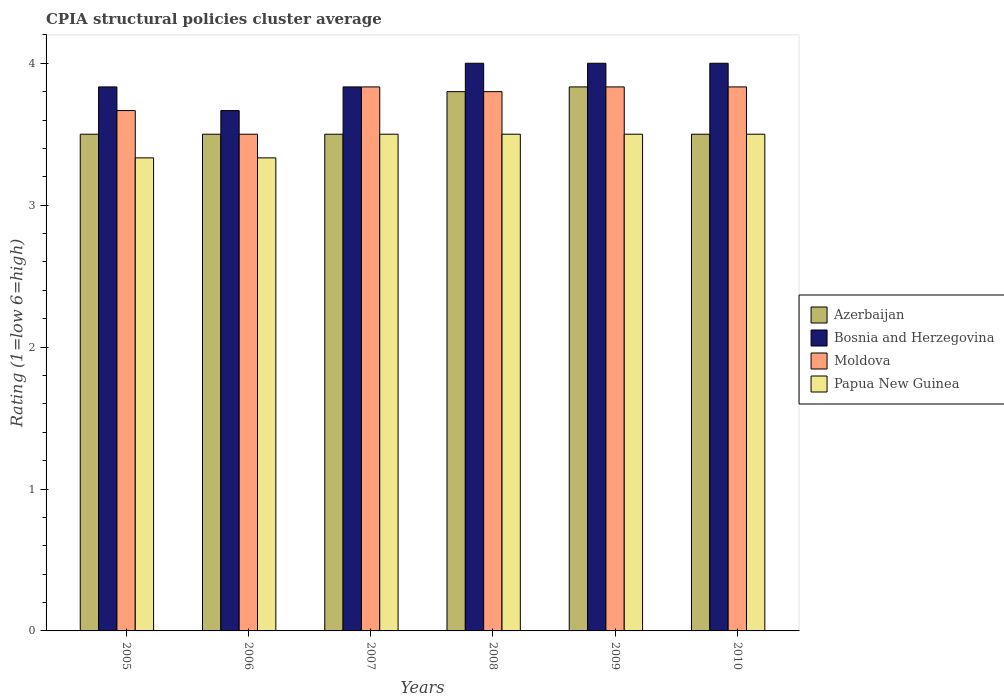How many different coloured bars are there?
Your answer should be very brief. 4. How many bars are there on the 4th tick from the left?
Provide a short and direct response. 4. What is the label of the 6th group of bars from the left?
Give a very brief answer. 2010. In how many cases, is the number of bars for a given year not equal to the number of legend labels?
Your answer should be compact. 0. What is the CPIA rating in Bosnia and Herzegovina in 2005?
Offer a very short reply. 3.83. Across all years, what is the maximum CPIA rating in Moldova?
Your response must be concise. 3.83. Across all years, what is the minimum CPIA rating in Azerbaijan?
Give a very brief answer. 3.5. What is the total CPIA rating in Azerbaijan in the graph?
Your answer should be compact. 21.63. What is the average CPIA rating in Moldova per year?
Offer a very short reply. 3.74. In the year 2007, what is the difference between the CPIA rating in Bosnia and Herzegovina and CPIA rating in Azerbaijan?
Offer a very short reply. 0.33. In how many years, is the CPIA rating in Papua New Guinea greater than 1?
Your answer should be compact. 6. What is the ratio of the CPIA rating in Azerbaijan in 2006 to that in 2008?
Give a very brief answer. 0.92. Is the CPIA rating in Moldova in 2007 less than that in 2008?
Offer a very short reply. No. Is the difference between the CPIA rating in Bosnia and Herzegovina in 2009 and 2010 greater than the difference between the CPIA rating in Azerbaijan in 2009 and 2010?
Your answer should be very brief. No. What is the difference between the highest and the second highest CPIA rating in Azerbaijan?
Offer a very short reply. 0.03. What is the difference between the highest and the lowest CPIA rating in Papua New Guinea?
Your answer should be very brief. 0.17. In how many years, is the CPIA rating in Bosnia and Herzegovina greater than the average CPIA rating in Bosnia and Herzegovina taken over all years?
Your answer should be very brief. 3. Is the sum of the CPIA rating in Azerbaijan in 2005 and 2006 greater than the maximum CPIA rating in Papua New Guinea across all years?
Ensure brevity in your answer.  Yes. What does the 1st bar from the left in 2005 represents?
Ensure brevity in your answer.  Azerbaijan. What does the 3rd bar from the right in 2007 represents?
Offer a very short reply. Bosnia and Herzegovina. How many years are there in the graph?
Offer a terse response. 6. What is the difference between two consecutive major ticks on the Y-axis?
Give a very brief answer. 1. Does the graph contain grids?
Your answer should be very brief. No. Where does the legend appear in the graph?
Provide a succinct answer. Center right. How many legend labels are there?
Provide a succinct answer. 4. How are the legend labels stacked?
Provide a succinct answer. Vertical. What is the title of the graph?
Your answer should be very brief. CPIA structural policies cluster average. Does "Burkina Faso" appear as one of the legend labels in the graph?
Give a very brief answer. No. What is the label or title of the Y-axis?
Your response must be concise. Rating (1=low 6=high). What is the Rating (1=low 6=high) of Bosnia and Herzegovina in 2005?
Ensure brevity in your answer.  3.83. What is the Rating (1=low 6=high) of Moldova in 2005?
Ensure brevity in your answer.  3.67. What is the Rating (1=low 6=high) of Papua New Guinea in 2005?
Give a very brief answer. 3.33. What is the Rating (1=low 6=high) in Azerbaijan in 2006?
Your answer should be compact. 3.5. What is the Rating (1=low 6=high) in Bosnia and Herzegovina in 2006?
Ensure brevity in your answer.  3.67. What is the Rating (1=low 6=high) in Moldova in 2006?
Give a very brief answer. 3.5. What is the Rating (1=low 6=high) in Papua New Guinea in 2006?
Give a very brief answer. 3.33. What is the Rating (1=low 6=high) of Bosnia and Herzegovina in 2007?
Keep it short and to the point. 3.83. What is the Rating (1=low 6=high) of Moldova in 2007?
Offer a terse response. 3.83. What is the Rating (1=low 6=high) of Papua New Guinea in 2007?
Give a very brief answer. 3.5. What is the Rating (1=low 6=high) of Azerbaijan in 2008?
Offer a terse response. 3.8. What is the Rating (1=low 6=high) of Bosnia and Herzegovina in 2008?
Provide a short and direct response. 4. What is the Rating (1=low 6=high) of Papua New Guinea in 2008?
Offer a terse response. 3.5. What is the Rating (1=low 6=high) in Azerbaijan in 2009?
Make the answer very short. 3.83. What is the Rating (1=low 6=high) of Moldova in 2009?
Provide a succinct answer. 3.83. What is the Rating (1=low 6=high) in Azerbaijan in 2010?
Your answer should be compact. 3.5. What is the Rating (1=low 6=high) of Bosnia and Herzegovina in 2010?
Ensure brevity in your answer.  4. What is the Rating (1=low 6=high) in Moldova in 2010?
Ensure brevity in your answer.  3.83. What is the Rating (1=low 6=high) in Papua New Guinea in 2010?
Offer a terse response. 3.5. Across all years, what is the maximum Rating (1=low 6=high) of Azerbaijan?
Provide a succinct answer. 3.83. Across all years, what is the maximum Rating (1=low 6=high) of Moldova?
Your answer should be very brief. 3.83. Across all years, what is the minimum Rating (1=low 6=high) of Azerbaijan?
Provide a short and direct response. 3.5. Across all years, what is the minimum Rating (1=low 6=high) in Bosnia and Herzegovina?
Your answer should be compact. 3.67. Across all years, what is the minimum Rating (1=low 6=high) in Papua New Guinea?
Give a very brief answer. 3.33. What is the total Rating (1=low 6=high) of Azerbaijan in the graph?
Offer a very short reply. 21.63. What is the total Rating (1=low 6=high) in Bosnia and Herzegovina in the graph?
Your answer should be compact. 23.33. What is the total Rating (1=low 6=high) in Moldova in the graph?
Your answer should be very brief. 22.47. What is the total Rating (1=low 6=high) of Papua New Guinea in the graph?
Your answer should be compact. 20.67. What is the difference between the Rating (1=low 6=high) of Azerbaijan in 2005 and that in 2006?
Keep it short and to the point. 0. What is the difference between the Rating (1=low 6=high) in Papua New Guinea in 2005 and that in 2006?
Provide a succinct answer. 0. What is the difference between the Rating (1=low 6=high) of Moldova in 2005 and that in 2007?
Offer a very short reply. -0.17. What is the difference between the Rating (1=low 6=high) of Papua New Guinea in 2005 and that in 2007?
Provide a succinct answer. -0.17. What is the difference between the Rating (1=low 6=high) in Azerbaijan in 2005 and that in 2008?
Make the answer very short. -0.3. What is the difference between the Rating (1=low 6=high) in Bosnia and Herzegovina in 2005 and that in 2008?
Make the answer very short. -0.17. What is the difference between the Rating (1=low 6=high) of Moldova in 2005 and that in 2008?
Your response must be concise. -0.13. What is the difference between the Rating (1=low 6=high) of Azerbaijan in 2005 and that in 2009?
Offer a terse response. -0.33. What is the difference between the Rating (1=low 6=high) in Bosnia and Herzegovina in 2005 and that in 2009?
Your answer should be very brief. -0.17. What is the difference between the Rating (1=low 6=high) of Moldova in 2005 and that in 2009?
Ensure brevity in your answer.  -0.17. What is the difference between the Rating (1=low 6=high) in Papua New Guinea in 2005 and that in 2009?
Give a very brief answer. -0.17. What is the difference between the Rating (1=low 6=high) in Bosnia and Herzegovina in 2005 and that in 2010?
Your response must be concise. -0.17. What is the difference between the Rating (1=low 6=high) of Papua New Guinea in 2005 and that in 2010?
Provide a short and direct response. -0.17. What is the difference between the Rating (1=low 6=high) in Azerbaijan in 2006 and that in 2007?
Ensure brevity in your answer.  0. What is the difference between the Rating (1=low 6=high) of Bosnia and Herzegovina in 2006 and that in 2007?
Your answer should be very brief. -0.17. What is the difference between the Rating (1=low 6=high) of Moldova in 2006 and that in 2007?
Provide a short and direct response. -0.33. What is the difference between the Rating (1=low 6=high) in Azerbaijan in 2006 and that in 2008?
Provide a short and direct response. -0.3. What is the difference between the Rating (1=low 6=high) of Moldova in 2006 and that in 2008?
Your response must be concise. -0.3. What is the difference between the Rating (1=low 6=high) of Papua New Guinea in 2006 and that in 2008?
Offer a very short reply. -0.17. What is the difference between the Rating (1=low 6=high) of Azerbaijan in 2006 and that in 2009?
Make the answer very short. -0.33. What is the difference between the Rating (1=low 6=high) of Bosnia and Herzegovina in 2006 and that in 2009?
Your response must be concise. -0.33. What is the difference between the Rating (1=low 6=high) of Papua New Guinea in 2006 and that in 2009?
Your response must be concise. -0.17. What is the difference between the Rating (1=low 6=high) in Azerbaijan in 2006 and that in 2010?
Provide a short and direct response. 0. What is the difference between the Rating (1=low 6=high) of Bosnia and Herzegovina in 2006 and that in 2010?
Offer a very short reply. -0.33. What is the difference between the Rating (1=low 6=high) in Moldova in 2007 and that in 2008?
Your answer should be compact. 0.03. What is the difference between the Rating (1=low 6=high) of Bosnia and Herzegovina in 2007 and that in 2009?
Your response must be concise. -0.17. What is the difference between the Rating (1=low 6=high) in Papua New Guinea in 2007 and that in 2009?
Provide a succinct answer. 0. What is the difference between the Rating (1=low 6=high) in Moldova in 2007 and that in 2010?
Provide a short and direct response. 0. What is the difference between the Rating (1=low 6=high) of Azerbaijan in 2008 and that in 2009?
Provide a succinct answer. -0.03. What is the difference between the Rating (1=low 6=high) in Bosnia and Herzegovina in 2008 and that in 2009?
Give a very brief answer. 0. What is the difference between the Rating (1=low 6=high) in Moldova in 2008 and that in 2009?
Keep it short and to the point. -0.03. What is the difference between the Rating (1=low 6=high) in Azerbaijan in 2008 and that in 2010?
Provide a short and direct response. 0.3. What is the difference between the Rating (1=low 6=high) in Moldova in 2008 and that in 2010?
Give a very brief answer. -0.03. What is the difference between the Rating (1=low 6=high) of Bosnia and Herzegovina in 2009 and that in 2010?
Provide a short and direct response. 0. What is the difference between the Rating (1=low 6=high) in Moldova in 2009 and that in 2010?
Your response must be concise. 0. What is the difference between the Rating (1=low 6=high) of Azerbaijan in 2005 and the Rating (1=low 6=high) of Papua New Guinea in 2006?
Offer a terse response. 0.17. What is the difference between the Rating (1=low 6=high) in Bosnia and Herzegovina in 2005 and the Rating (1=low 6=high) in Moldova in 2006?
Offer a very short reply. 0.33. What is the difference between the Rating (1=low 6=high) in Bosnia and Herzegovina in 2005 and the Rating (1=low 6=high) in Papua New Guinea in 2006?
Provide a succinct answer. 0.5. What is the difference between the Rating (1=low 6=high) of Azerbaijan in 2005 and the Rating (1=low 6=high) of Bosnia and Herzegovina in 2007?
Your response must be concise. -0.33. What is the difference between the Rating (1=low 6=high) of Bosnia and Herzegovina in 2005 and the Rating (1=low 6=high) of Moldova in 2007?
Your answer should be very brief. 0. What is the difference between the Rating (1=low 6=high) in Moldova in 2005 and the Rating (1=low 6=high) in Papua New Guinea in 2007?
Make the answer very short. 0.17. What is the difference between the Rating (1=low 6=high) of Azerbaijan in 2005 and the Rating (1=low 6=high) of Moldova in 2008?
Keep it short and to the point. -0.3. What is the difference between the Rating (1=low 6=high) in Azerbaijan in 2005 and the Rating (1=low 6=high) in Papua New Guinea in 2008?
Offer a very short reply. 0. What is the difference between the Rating (1=low 6=high) of Bosnia and Herzegovina in 2005 and the Rating (1=low 6=high) of Moldova in 2008?
Your answer should be very brief. 0.03. What is the difference between the Rating (1=low 6=high) of Bosnia and Herzegovina in 2005 and the Rating (1=low 6=high) of Papua New Guinea in 2008?
Make the answer very short. 0.33. What is the difference between the Rating (1=low 6=high) in Moldova in 2005 and the Rating (1=low 6=high) in Papua New Guinea in 2008?
Your response must be concise. 0.17. What is the difference between the Rating (1=low 6=high) in Azerbaijan in 2005 and the Rating (1=low 6=high) in Bosnia and Herzegovina in 2009?
Offer a very short reply. -0.5. What is the difference between the Rating (1=low 6=high) of Azerbaijan in 2005 and the Rating (1=low 6=high) of Moldova in 2009?
Give a very brief answer. -0.33. What is the difference between the Rating (1=low 6=high) of Azerbaijan in 2005 and the Rating (1=low 6=high) of Papua New Guinea in 2009?
Your answer should be very brief. 0. What is the difference between the Rating (1=low 6=high) of Moldova in 2005 and the Rating (1=low 6=high) of Papua New Guinea in 2009?
Offer a terse response. 0.17. What is the difference between the Rating (1=low 6=high) of Azerbaijan in 2005 and the Rating (1=low 6=high) of Bosnia and Herzegovina in 2010?
Your answer should be compact. -0.5. What is the difference between the Rating (1=low 6=high) of Azerbaijan in 2005 and the Rating (1=low 6=high) of Moldova in 2010?
Make the answer very short. -0.33. What is the difference between the Rating (1=low 6=high) of Bosnia and Herzegovina in 2005 and the Rating (1=low 6=high) of Moldova in 2010?
Your response must be concise. 0. What is the difference between the Rating (1=low 6=high) of Azerbaijan in 2006 and the Rating (1=low 6=high) of Bosnia and Herzegovina in 2007?
Keep it short and to the point. -0.33. What is the difference between the Rating (1=low 6=high) of Azerbaijan in 2006 and the Rating (1=low 6=high) of Papua New Guinea in 2007?
Your answer should be very brief. 0. What is the difference between the Rating (1=low 6=high) in Bosnia and Herzegovina in 2006 and the Rating (1=low 6=high) in Papua New Guinea in 2007?
Your answer should be very brief. 0.17. What is the difference between the Rating (1=low 6=high) of Moldova in 2006 and the Rating (1=low 6=high) of Papua New Guinea in 2007?
Offer a terse response. 0. What is the difference between the Rating (1=low 6=high) in Azerbaijan in 2006 and the Rating (1=low 6=high) in Bosnia and Herzegovina in 2008?
Your answer should be very brief. -0.5. What is the difference between the Rating (1=low 6=high) in Azerbaijan in 2006 and the Rating (1=low 6=high) in Moldova in 2008?
Give a very brief answer. -0.3. What is the difference between the Rating (1=low 6=high) of Bosnia and Herzegovina in 2006 and the Rating (1=low 6=high) of Moldova in 2008?
Provide a succinct answer. -0.13. What is the difference between the Rating (1=low 6=high) in Bosnia and Herzegovina in 2006 and the Rating (1=low 6=high) in Papua New Guinea in 2008?
Your response must be concise. 0.17. What is the difference between the Rating (1=low 6=high) in Azerbaijan in 2006 and the Rating (1=low 6=high) in Bosnia and Herzegovina in 2009?
Ensure brevity in your answer.  -0.5. What is the difference between the Rating (1=low 6=high) of Bosnia and Herzegovina in 2006 and the Rating (1=low 6=high) of Papua New Guinea in 2009?
Your answer should be very brief. 0.17. What is the difference between the Rating (1=low 6=high) in Azerbaijan in 2006 and the Rating (1=low 6=high) in Bosnia and Herzegovina in 2010?
Provide a succinct answer. -0.5. What is the difference between the Rating (1=low 6=high) in Azerbaijan in 2006 and the Rating (1=low 6=high) in Papua New Guinea in 2010?
Ensure brevity in your answer.  0. What is the difference between the Rating (1=low 6=high) in Bosnia and Herzegovina in 2007 and the Rating (1=low 6=high) in Papua New Guinea in 2008?
Ensure brevity in your answer.  0.33. What is the difference between the Rating (1=low 6=high) in Moldova in 2007 and the Rating (1=low 6=high) in Papua New Guinea in 2008?
Offer a very short reply. 0.33. What is the difference between the Rating (1=low 6=high) in Azerbaijan in 2007 and the Rating (1=low 6=high) in Papua New Guinea in 2010?
Make the answer very short. 0. What is the difference between the Rating (1=low 6=high) of Bosnia and Herzegovina in 2007 and the Rating (1=low 6=high) of Moldova in 2010?
Ensure brevity in your answer.  0. What is the difference between the Rating (1=low 6=high) in Moldova in 2007 and the Rating (1=low 6=high) in Papua New Guinea in 2010?
Make the answer very short. 0.33. What is the difference between the Rating (1=low 6=high) of Azerbaijan in 2008 and the Rating (1=low 6=high) of Bosnia and Herzegovina in 2009?
Keep it short and to the point. -0.2. What is the difference between the Rating (1=low 6=high) in Azerbaijan in 2008 and the Rating (1=low 6=high) in Moldova in 2009?
Your answer should be compact. -0.03. What is the difference between the Rating (1=low 6=high) of Bosnia and Herzegovina in 2008 and the Rating (1=low 6=high) of Papua New Guinea in 2009?
Ensure brevity in your answer.  0.5. What is the difference between the Rating (1=low 6=high) in Moldova in 2008 and the Rating (1=low 6=high) in Papua New Guinea in 2009?
Provide a short and direct response. 0.3. What is the difference between the Rating (1=low 6=high) in Azerbaijan in 2008 and the Rating (1=low 6=high) in Moldova in 2010?
Your answer should be very brief. -0.03. What is the difference between the Rating (1=low 6=high) in Bosnia and Herzegovina in 2008 and the Rating (1=low 6=high) in Moldova in 2010?
Keep it short and to the point. 0.17. What is the difference between the Rating (1=low 6=high) of Bosnia and Herzegovina in 2008 and the Rating (1=low 6=high) of Papua New Guinea in 2010?
Provide a short and direct response. 0.5. What is the difference between the Rating (1=low 6=high) of Azerbaijan in 2009 and the Rating (1=low 6=high) of Bosnia and Herzegovina in 2010?
Your answer should be compact. -0.17. What is the difference between the Rating (1=low 6=high) in Azerbaijan in 2009 and the Rating (1=low 6=high) in Moldova in 2010?
Your answer should be compact. 0. What is the difference between the Rating (1=low 6=high) of Bosnia and Herzegovina in 2009 and the Rating (1=low 6=high) of Papua New Guinea in 2010?
Your answer should be very brief. 0.5. What is the average Rating (1=low 6=high) in Azerbaijan per year?
Your answer should be compact. 3.61. What is the average Rating (1=low 6=high) of Bosnia and Herzegovina per year?
Offer a terse response. 3.89. What is the average Rating (1=low 6=high) of Moldova per year?
Make the answer very short. 3.74. What is the average Rating (1=low 6=high) of Papua New Guinea per year?
Offer a terse response. 3.44. In the year 2005, what is the difference between the Rating (1=low 6=high) in Azerbaijan and Rating (1=low 6=high) in Bosnia and Herzegovina?
Keep it short and to the point. -0.33. In the year 2005, what is the difference between the Rating (1=low 6=high) in Azerbaijan and Rating (1=low 6=high) in Papua New Guinea?
Offer a very short reply. 0.17. In the year 2005, what is the difference between the Rating (1=low 6=high) in Bosnia and Herzegovina and Rating (1=low 6=high) in Moldova?
Make the answer very short. 0.17. In the year 2006, what is the difference between the Rating (1=low 6=high) in Azerbaijan and Rating (1=low 6=high) in Moldova?
Your answer should be very brief. 0. In the year 2006, what is the difference between the Rating (1=low 6=high) in Bosnia and Herzegovina and Rating (1=low 6=high) in Moldova?
Your answer should be very brief. 0.17. In the year 2006, what is the difference between the Rating (1=low 6=high) in Bosnia and Herzegovina and Rating (1=low 6=high) in Papua New Guinea?
Give a very brief answer. 0.33. In the year 2006, what is the difference between the Rating (1=low 6=high) of Moldova and Rating (1=low 6=high) of Papua New Guinea?
Your answer should be very brief. 0.17. In the year 2007, what is the difference between the Rating (1=low 6=high) of Azerbaijan and Rating (1=low 6=high) of Papua New Guinea?
Your response must be concise. 0. In the year 2007, what is the difference between the Rating (1=low 6=high) in Bosnia and Herzegovina and Rating (1=low 6=high) in Moldova?
Provide a short and direct response. 0. In the year 2007, what is the difference between the Rating (1=low 6=high) of Bosnia and Herzegovina and Rating (1=low 6=high) of Papua New Guinea?
Offer a terse response. 0.33. In the year 2007, what is the difference between the Rating (1=low 6=high) in Moldova and Rating (1=low 6=high) in Papua New Guinea?
Make the answer very short. 0.33. In the year 2008, what is the difference between the Rating (1=low 6=high) of Azerbaijan and Rating (1=low 6=high) of Papua New Guinea?
Keep it short and to the point. 0.3. In the year 2008, what is the difference between the Rating (1=low 6=high) of Bosnia and Herzegovina and Rating (1=low 6=high) of Moldova?
Provide a short and direct response. 0.2. In the year 2008, what is the difference between the Rating (1=low 6=high) in Bosnia and Herzegovina and Rating (1=low 6=high) in Papua New Guinea?
Provide a succinct answer. 0.5. In the year 2008, what is the difference between the Rating (1=low 6=high) of Moldova and Rating (1=low 6=high) of Papua New Guinea?
Give a very brief answer. 0.3. In the year 2009, what is the difference between the Rating (1=low 6=high) in Azerbaijan and Rating (1=low 6=high) in Bosnia and Herzegovina?
Offer a very short reply. -0.17. In the year 2009, what is the difference between the Rating (1=low 6=high) of Bosnia and Herzegovina and Rating (1=low 6=high) of Moldova?
Provide a short and direct response. 0.17. In the year 2009, what is the difference between the Rating (1=low 6=high) of Bosnia and Herzegovina and Rating (1=low 6=high) of Papua New Guinea?
Your answer should be compact. 0.5. In the year 2010, what is the difference between the Rating (1=low 6=high) in Azerbaijan and Rating (1=low 6=high) in Moldova?
Provide a succinct answer. -0.33. In the year 2010, what is the difference between the Rating (1=low 6=high) in Azerbaijan and Rating (1=low 6=high) in Papua New Guinea?
Give a very brief answer. 0. In the year 2010, what is the difference between the Rating (1=low 6=high) of Moldova and Rating (1=low 6=high) of Papua New Guinea?
Offer a terse response. 0.33. What is the ratio of the Rating (1=low 6=high) in Azerbaijan in 2005 to that in 2006?
Provide a short and direct response. 1. What is the ratio of the Rating (1=low 6=high) in Bosnia and Herzegovina in 2005 to that in 2006?
Ensure brevity in your answer.  1.05. What is the ratio of the Rating (1=low 6=high) of Moldova in 2005 to that in 2006?
Offer a terse response. 1.05. What is the ratio of the Rating (1=low 6=high) in Papua New Guinea in 2005 to that in 2006?
Provide a short and direct response. 1. What is the ratio of the Rating (1=low 6=high) in Moldova in 2005 to that in 2007?
Offer a terse response. 0.96. What is the ratio of the Rating (1=low 6=high) in Azerbaijan in 2005 to that in 2008?
Make the answer very short. 0.92. What is the ratio of the Rating (1=low 6=high) of Bosnia and Herzegovina in 2005 to that in 2008?
Your response must be concise. 0.96. What is the ratio of the Rating (1=low 6=high) of Moldova in 2005 to that in 2008?
Your answer should be compact. 0.96. What is the ratio of the Rating (1=low 6=high) of Papua New Guinea in 2005 to that in 2008?
Your answer should be compact. 0.95. What is the ratio of the Rating (1=low 6=high) in Azerbaijan in 2005 to that in 2009?
Your response must be concise. 0.91. What is the ratio of the Rating (1=low 6=high) of Bosnia and Herzegovina in 2005 to that in 2009?
Your answer should be very brief. 0.96. What is the ratio of the Rating (1=low 6=high) in Moldova in 2005 to that in 2009?
Give a very brief answer. 0.96. What is the ratio of the Rating (1=low 6=high) of Papua New Guinea in 2005 to that in 2009?
Make the answer very short. 0.95. What is the ratio of the Rating (1=low 6=high) of Moldova in 2005 to that in 2010?
Your answer should be compact. 0.96. What is the ratio of the Rating (1=low 6=high) of Papua New Guinea in 2005 to that in 2010?
Give a very brief answer. 0.95. What is the ratio of the Rating (1=low 6=high) of Azerbaijan in 2006 to that in 2007?
Provide a short and direct response. 1. What is the ratio of the Rating (1=low 6=high) in Bosnia and Herzegovina in 2006 to that in 2007?
Offer a terse response. 0.96. What is the ratio of the Rating (1=low 6=high) in Papua New Guinea in 2006 to that in 2007?
Offer a terse response. 0.95. What is the ratio of the Rating (1=low 6=high) of Azerbaijan in 2006 to that in 2008?
Your answer should be compact. 0.92. What is the ratio of the Rating (1=low 6=high) in Bosnia and Herzegovina in 2006 to that in 2008?
Your answer should be very brief. 0.92. What is the ratio of the Rating (1=low 6=high) in Moldova in 2006 to that in 2008?
Make the answer very short. 0.92. What is the ratio of the Rating (1=low 6=high) of Papua New Guinea in 2006 to that in 2008?
Offer a terse response. 0.95. What is the ratio of the Rating (1=low 6=high) in Azerbaijan in 2006 to that in 2009?
Your answer should be very brief. 0.91. What is the ratio of the Rating (1=low 6=high) of Moldova in 2006 to that in 2009?
Ensure brevity in your answer.  0.91. What is the ratio of the Rating (1=low 6=high) of Papua New Guinea in 2006 to that in 2009?
Your response must be concise. 0.95. What is the ratio of the Rating (1=low 6=high) of Azerbaijan in 2006 to that in 2010?
Keep it short and to the point. 1. What is the ratio of the Rating (1=low 6=high) of Bosnia and Herzegovina in 2006 to that in 2010?
Provide a succinct answer. 0.92. What is the ratio of the Rating (1=low 6=high) in Moldova in 2006 to that in 2010?
Make the answer very short. 0.91. What is the ratio of the Rating (1=low 6=high) in Papua New Guinea in 2006 to that in 2010?
Your answer should be compact. 0.95. What is the ratio of the Rating (1=low 6=high) of Azerbaijan in 2007 to that in 2008?
Keep it short and to the point. 0.92. What is the ratio of the Rating (1=low 6=high) in Bosnia and Herzegovina in 2007 to that in 2008?
Offer a very short reply. 0.96. What is the ratio of the Rating (1=low 6=high) in Moldova in 2007 to that in 2008?
Provide a succinct answer. 1.01. What is the ratio of the Rating (1=low 6=high) of Papua New Guinea in 2007 to that in 2008?
Your response must be concise. 1. What is the ratio of the Rating (1=low 6=high) in Azerbaijan in 2007 to that in 2009?
Ensure brevity in your answer.  0.91. What is the ratio of the Rating (1=low 6=high) in Moldova in 2007 to that in 2009?
Offer a terse response. 1. What is the ratio of the Rating (1=low 6=high) in Azerbaijan in 2007 to that in 2010?
Offer a terse response. 1. What is the ratio of the Rating (1=low 6=high) in Moldova in 2007 to that in 2010?
Give a very brief answer. 1. What is the ratio of the Rating (1=low 6=high) in Papua New Guinea in 2007 to that in 2010?
Give a very brief answer. 1. What is the ratio of the Rating (1=low 6=high) in Papua New Guinea in 2008 to that in 2009?
Ensure brevity in your answer.  1. What is the ratio of the Rating (1=low 6=high) in Azerbaijan in 2008 to that in 2010?
Your answer should be compact. 1.09. What is the ratio of the Rating (1=low 6=high) of Bosnia and Herzegovina in 2008 to that in 2010?
Offer a very short reply. 1. What is the ratio of the Rating (1=low 6=high) of Moldova in 2008 to that in 2010?
Your answer should be very brief. 0.99. What is the ratio of the Rating (1=low 6=high) of Papua New Guinea in 2008 to that in 2010?
Your answer should be compact. 1. What is the ratio of the Rating (1=low 6=high) of Azerbaijan in 2009 to that in 2010?
Make the answer very short. 1.1. What is the ratio of the Rating (1=low 6=high) of Papua New Guinea in 2009 to that in 2010?
Provide a succinct answer. 1. What is the difference between the highest and the lowest Rating (1=low 6=high) of Azerbaijan?
Provide a short and direct response. 0.33. What is the difference between the highest and the lowest Rating (1=low 6=high) in Bosnia and Herzegovina?
Offer a very short reply. 0.33. What is the difference between the highest and the lowest Rating (1=low 6=high) of Papua New Guinea?
Ensure brevity in your answer.  0.17. 